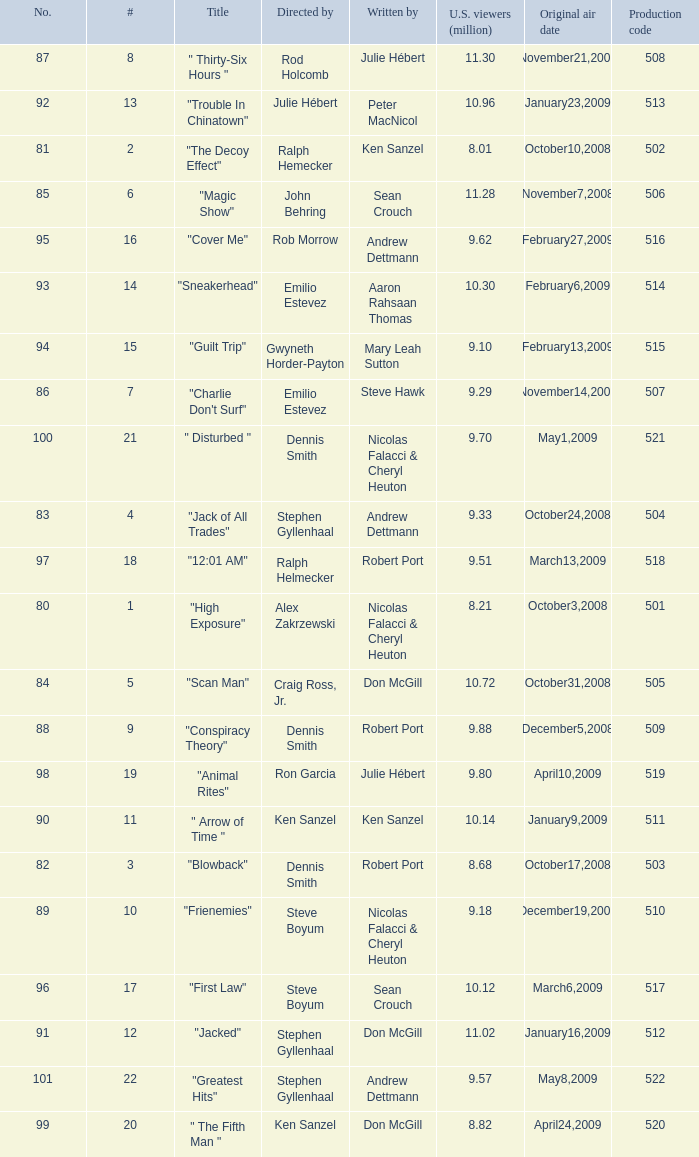Who wrote the episode with the production code 519? Julie Hébert. 